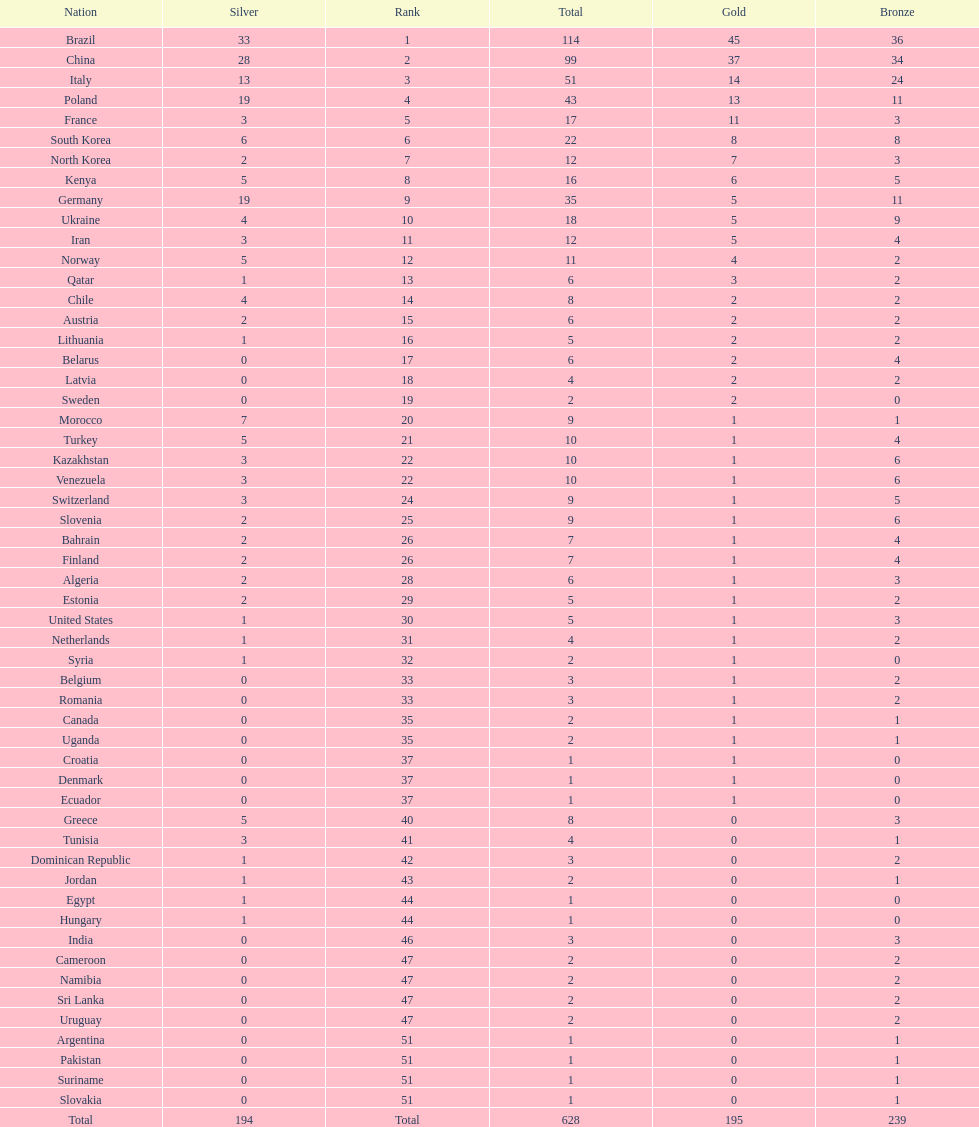Who only won 13 silver medals? Italy. 